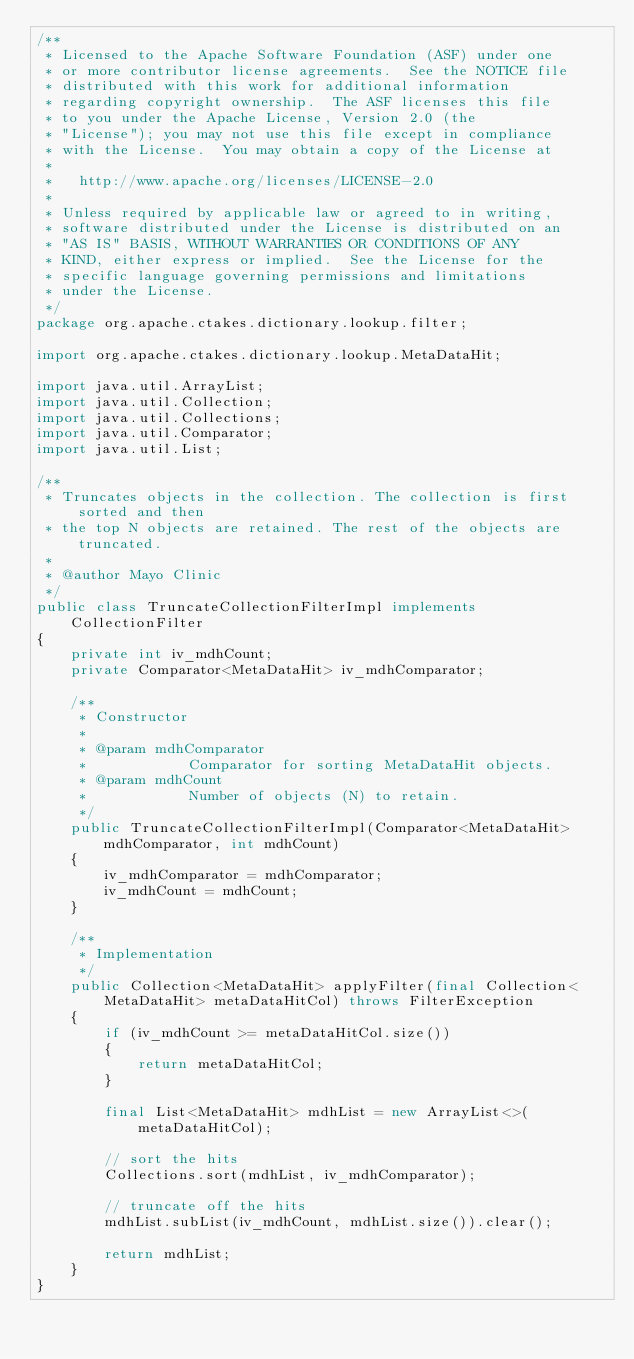<code> <loc_0><loc_0><loc_500><loc_500><_Java_>/**
 * Licensed to the Apache Software Foundation (ASF) under one
 * or more contributor license agreements.  See the NOTICE file
 * distributed with this work for additional information
 * regarding copyright ownership.  The ASF licenses this file
 * to you under the Apache License, Version 2.0 (the
 * "License"); you may not use this file except in compliance
 * with the License.  You may obtain a copy of the License at
 *
 *   http://www.apache.org/licenses/LICENSE-2.0
 *
 * Unless required by applicable law or agreed to in writing,
 * software distributed under the License is distributed on an
 * "AS IS" BASIS, WITHOUT WARRANTIES OR CONDITIONS OF ANY
 * KIND, either express or implied.  See the License for the
 * specific language governing permissions and limitations
 * under the License.
 */
package org.apache.ctakes.dictionary.lookup.filter;

import org.apache.ctakes.dictionary.lookup.MetaDataHit;

import java.util.ArrayList;
import java.util.Collection;
import java.util.Collections;
import java.util.Comparator;
import java.util.List;

/**
 * Truncates objects in the collection. The collection is first sorted and then
 * the top N objects are retained. The rest of the objects are truncated.
 * 
 * @author Mayo Clinic
 */
public class TruncateCollectionFilterImpl implements CollectionFilter
{
    private int iv_mdhCount;
    private Comparator<MetaDataHit> iv_mdhComparator;

    /**
     * Constructor
     * 
     * @param mdhComparator
     *            Comparator for sorting MetaDataHit objects.
     * @param mdhCount
     *            Number of objects (N) to retain.
     */
    public TruncateCollectionFilterImpl(Comparator<MetaDataHit> mdhComparator, int mdhCount)
    {
        iv_mdhComparator = mdhComparator;
        iv_mdhCount = mdhCount;
    }

    /**
     * Implementation
     */
    public Collection<MetaDataHit> applyFilter(final Collection<MetaDataHit> metaDataHitCol) throws FilterException
    {
        if (iv_mdhCount >= metaDataHitCol.size())
        {
            return metaDataHitCol;
        }
        
        final List<MetaDataHit> mdhList = new ArrayList<>(metaDataHitCol);

        // sort the hits
        Collections.sort(mdhList, iv_mdhComparator);

        // truncate off the hits
        mdhList.subList(iv_mdhCount, mdhList.size()).clear();
        
        return mdhList;
    }
}
</code> 